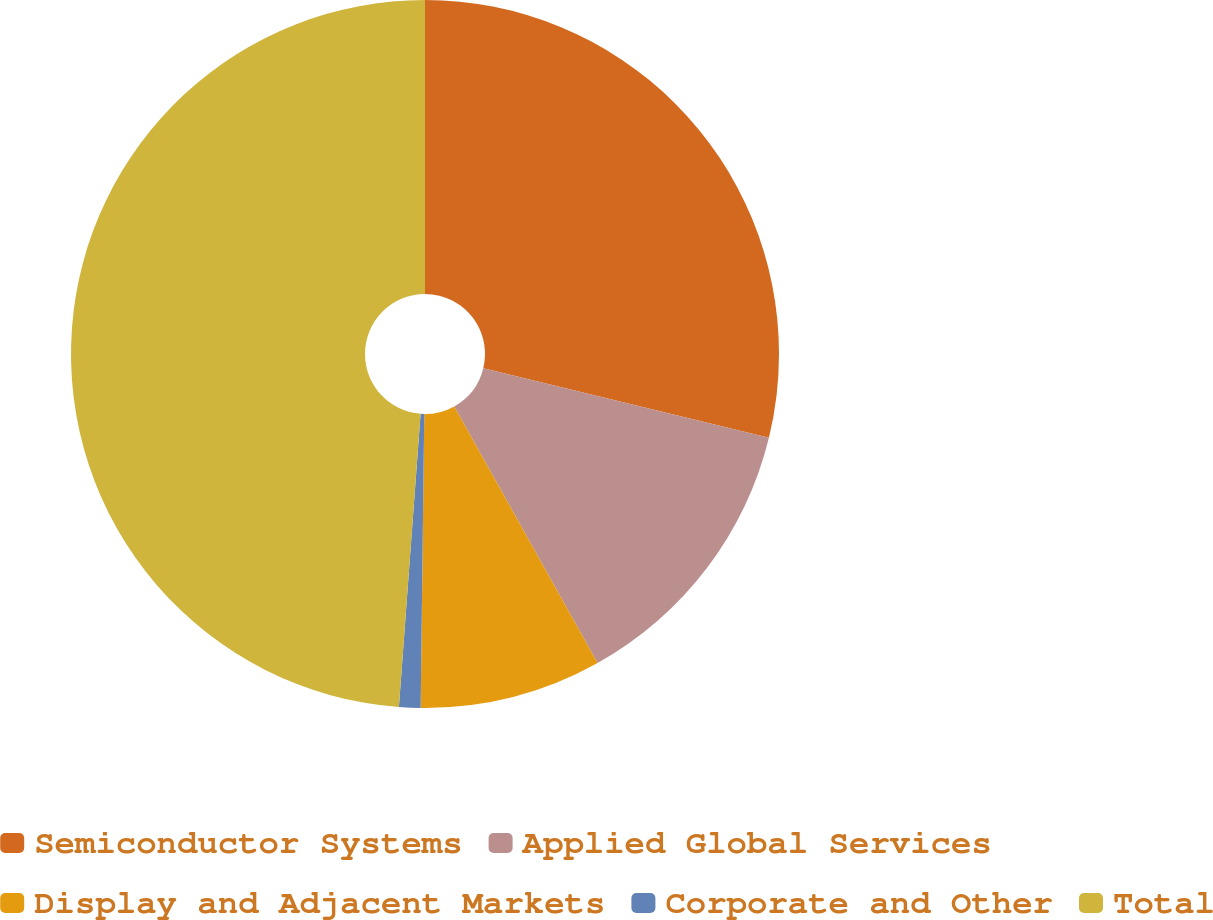Convert chart to OTSL. <chart><loc_0><loc_0><loc_500><loc_500><pie_chart><fcel>Semiconductor Systems<fcel>Applied Global Services<fcel>Display and Adjacent Markets<fcel>Corporate and Other<fcel>Total<nl><fcel>28.81%<fcel>13.09%<fcel>8.3%<fcel>0.98%<fcel>48.83%<nl></chart> 